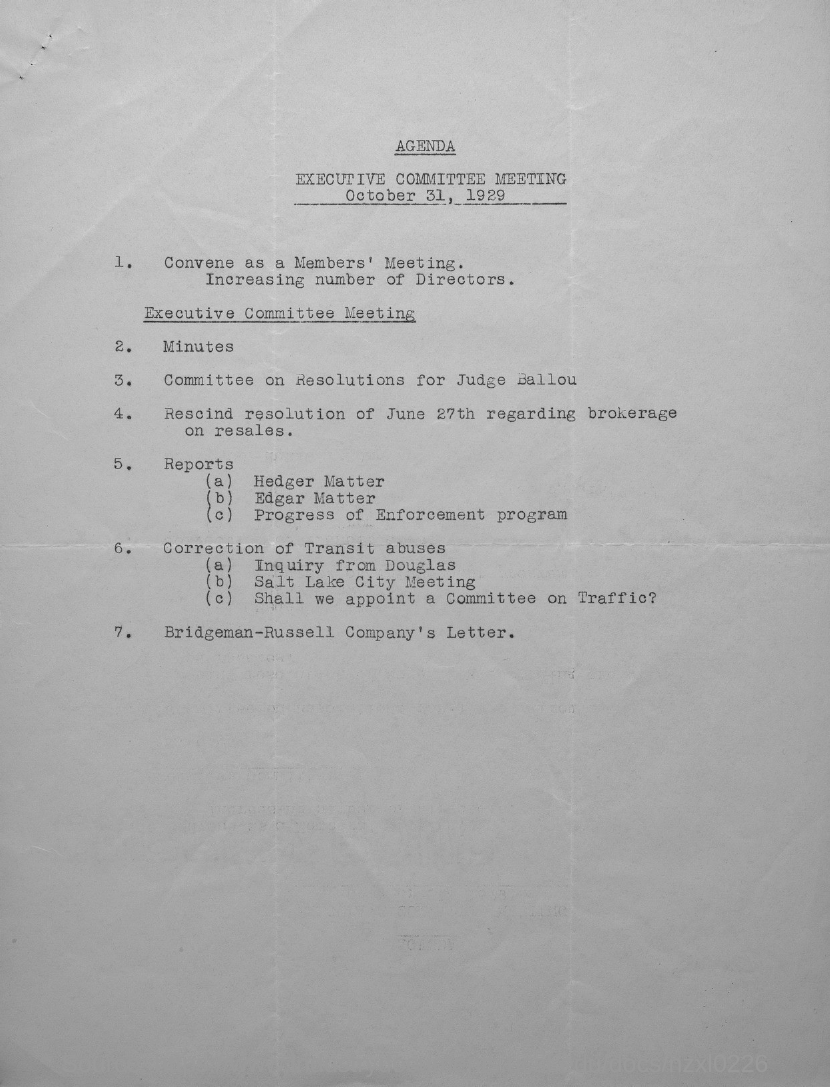Outline some significant characteristics in this image. The executive committee meeting is scheduled to be held on October 31, 1929. 